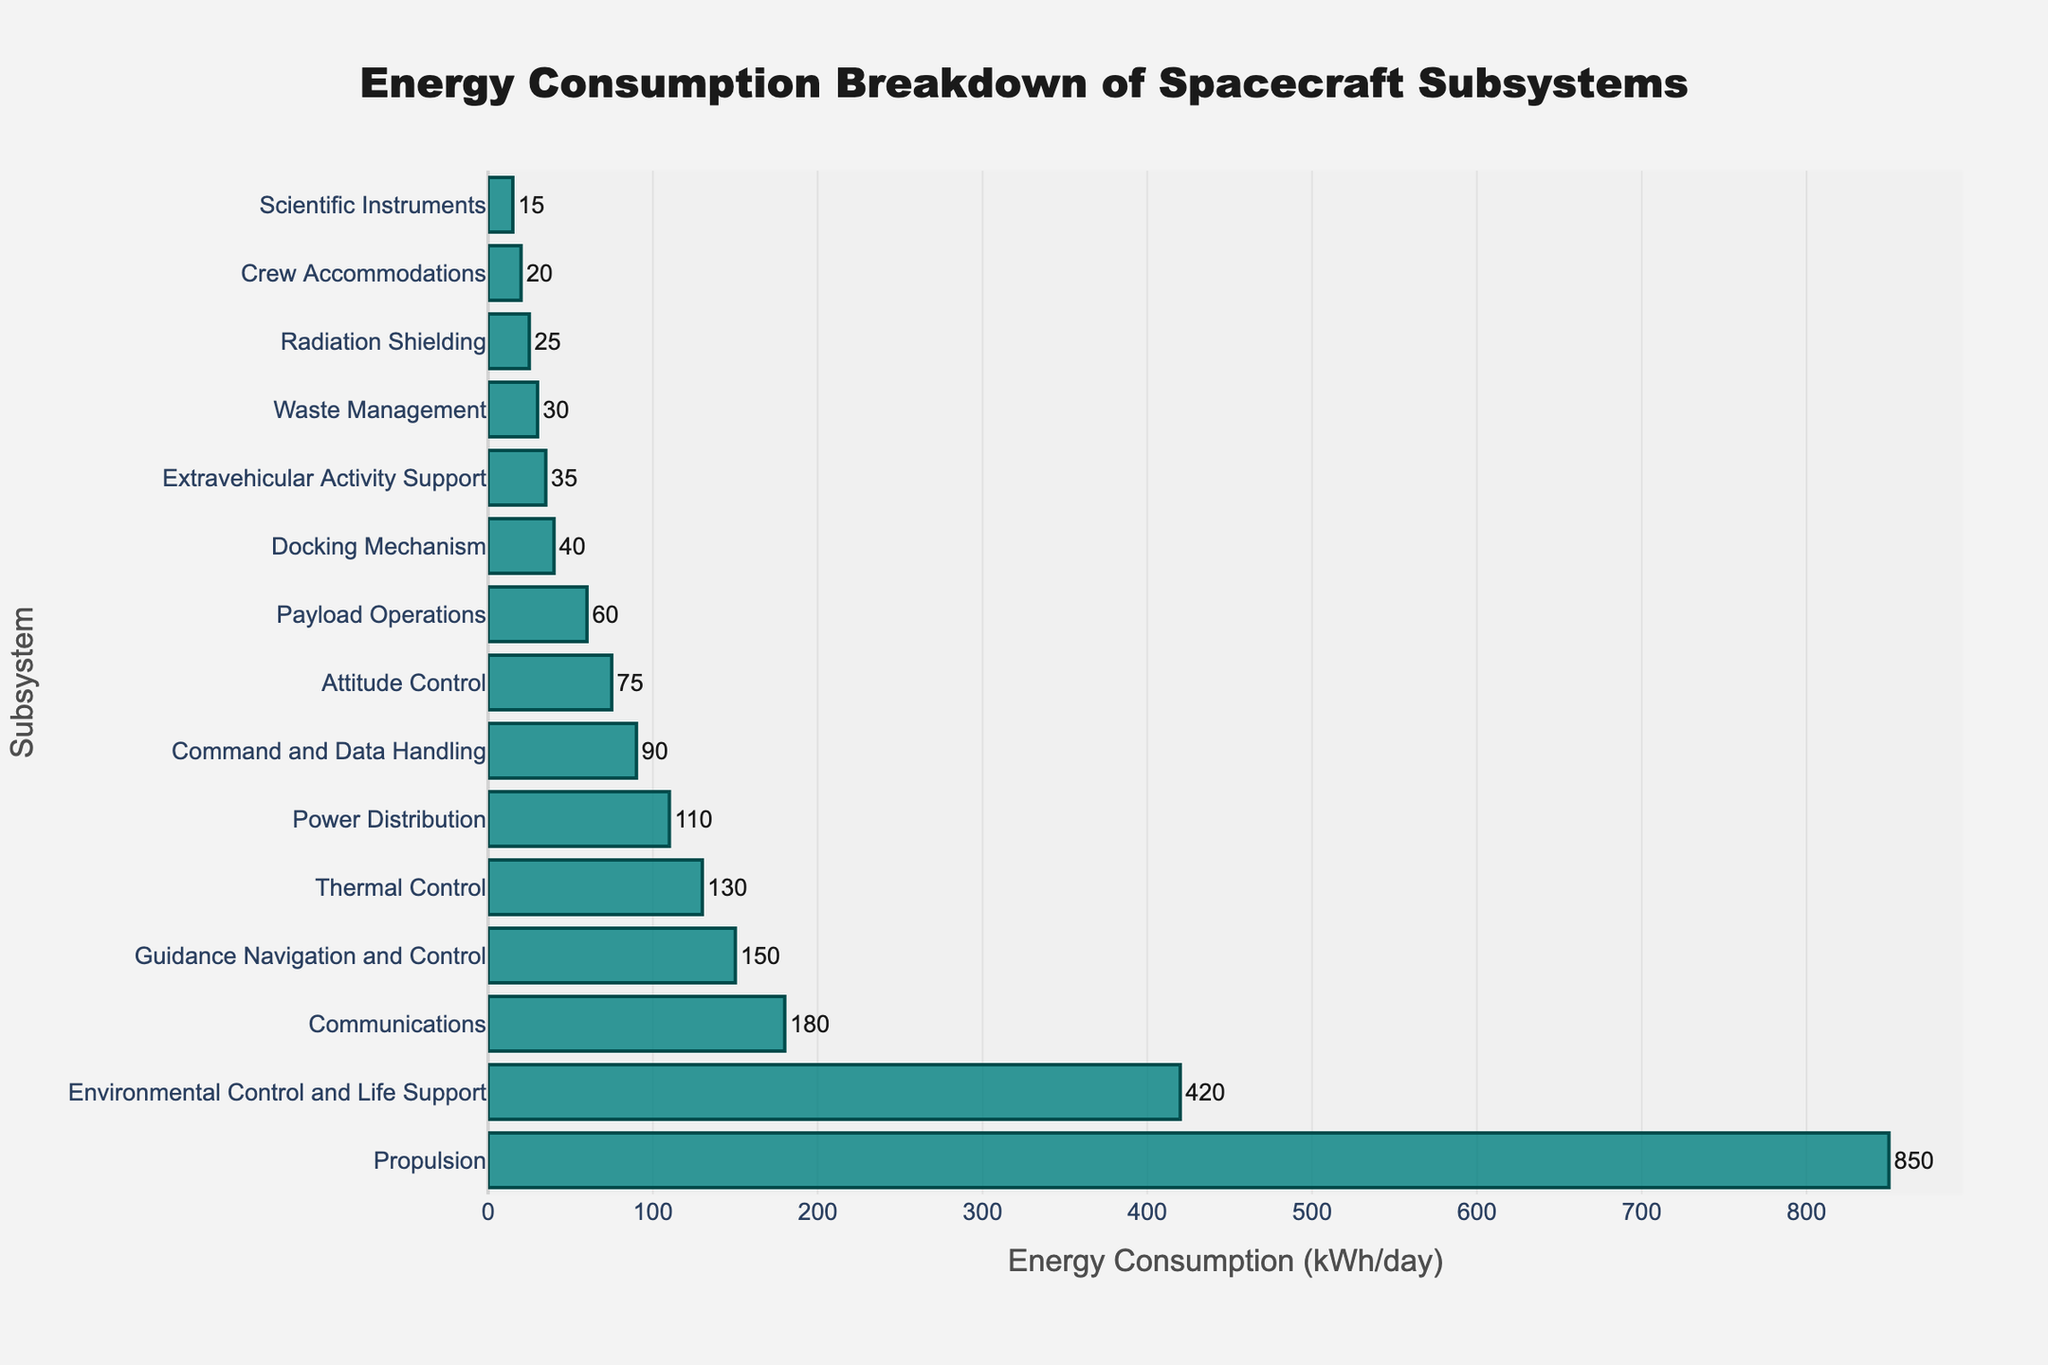Which subsystem consumes the most energy per day? The bar representing "Propulsion" is the longest, indicating the highest energy consumption.
Answer: Propulsion How does the energy consumption of Environmental Control and Life Support compare to that of Communications? The bar for Environmental Control and Life Support is longer than that for Communications, indicating more energy consumption.
Answer: Environmental Control and Life Support What is the combined energy consumption of the Payload Operations and Docking Mechanism subsystems? Add the values: Payload Operations (60 kWh/day) + Docking Mechanism (40 kWh/day) = 100 kWh/day.
Answer: 100 kWh/day Which subsystem uses the least energy? The shortest bar corresponds to "Scientific Instruments," indicating the lowest energy consumption.
Answer: Scientific Instruments How many subsystems consume less than 100 kWh/day? Count the subsystems with bars corresponding to values less than 100 kWh/day, which are Command and Data Handling, Attitude Control, Payload Operations, Docking Mechanism, Extravehicular Activity Support, Waste Management, Radiation Shielding, Crew Accommodations, and Scientific Instruments. There are 9 such subsystems.
Answer: 9 Is the energy consumption of Power Distribution greater than or less than Thermal Control? The bars show that Power Distribution (110 kWh/day) is slightly less than Thermal Control (130 kWh/day).
Answer: Less than What is the difference in energy consumption between Propulsion and Guidance Navigation and Control? Subtract the energy consumption values: Propulsion (850 kWh/day) - Guidance Navigation and Control (150 kWh/day) = 700 kWh/day.
Answer: 700 kWh/day Which two subsystems have the most similar energy consumption values? The bars for Waste Management (30 kWh/day) and Radiation Shielding (25 kWh/day) are closest in length, indicating similar values.
Answer: Waste Management and Radiation Shielding What fraction of the total energy consumption is used by the Propulsion subsystem? Sum all energy values, then divide the Propulsion value by this sum. Sum: 850 + 420 + 180 + 150 + 130 + 110 + 90 + 75 + 60 + 40 + 35 + 30 + 25 + 20 + 15 = 2230 kWh/day. Fraction = 850 / 2230 ≈ 0.3816.
Answer: Approximately 0.3816 What is the average energy consumption of the top three subsystems? Sum the top three values and divide by three: (850 + 420 + 180) / 3 = 1450 / 3 ≈ 483.33 kWh/day.
Answer: Approximately 483.33 kWh/day 